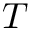Convert formula to latex. <formula><loc_0><loc_0><loc_500><loc_500>T</formula> 